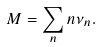<formula> <loc_0><loc_0><loc_500><loc_500>M = \sum _ { n } n \nu _ { n } .</formula> 